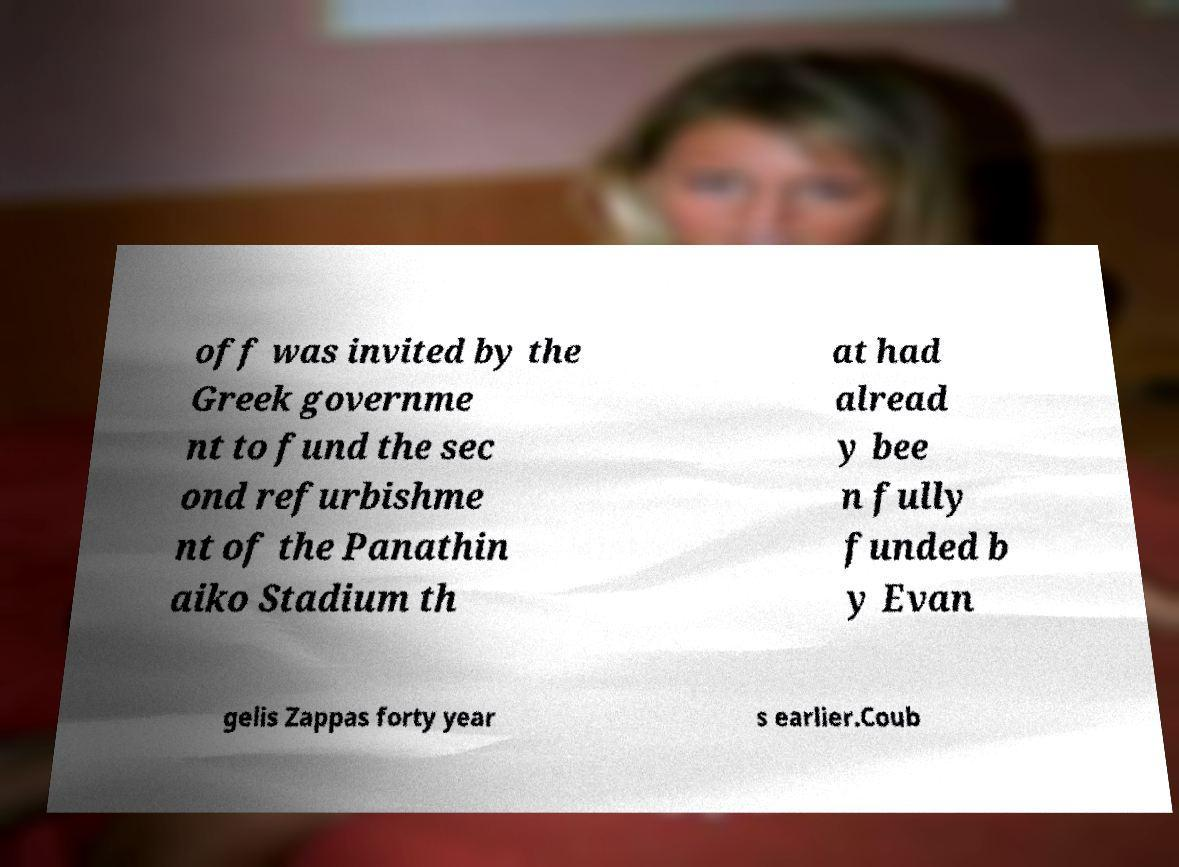Can you read and provide the text displayed in the image?This photo seems to have some interesting text. Can you extract and type it out for me? off was invited by the Greek governme nt to fund the sec ond refurbishme nt of the Panathin aiko Stadium th at had alread y bee n fully funded b y Evan gelis Zappas forty year s earlier.Coub 